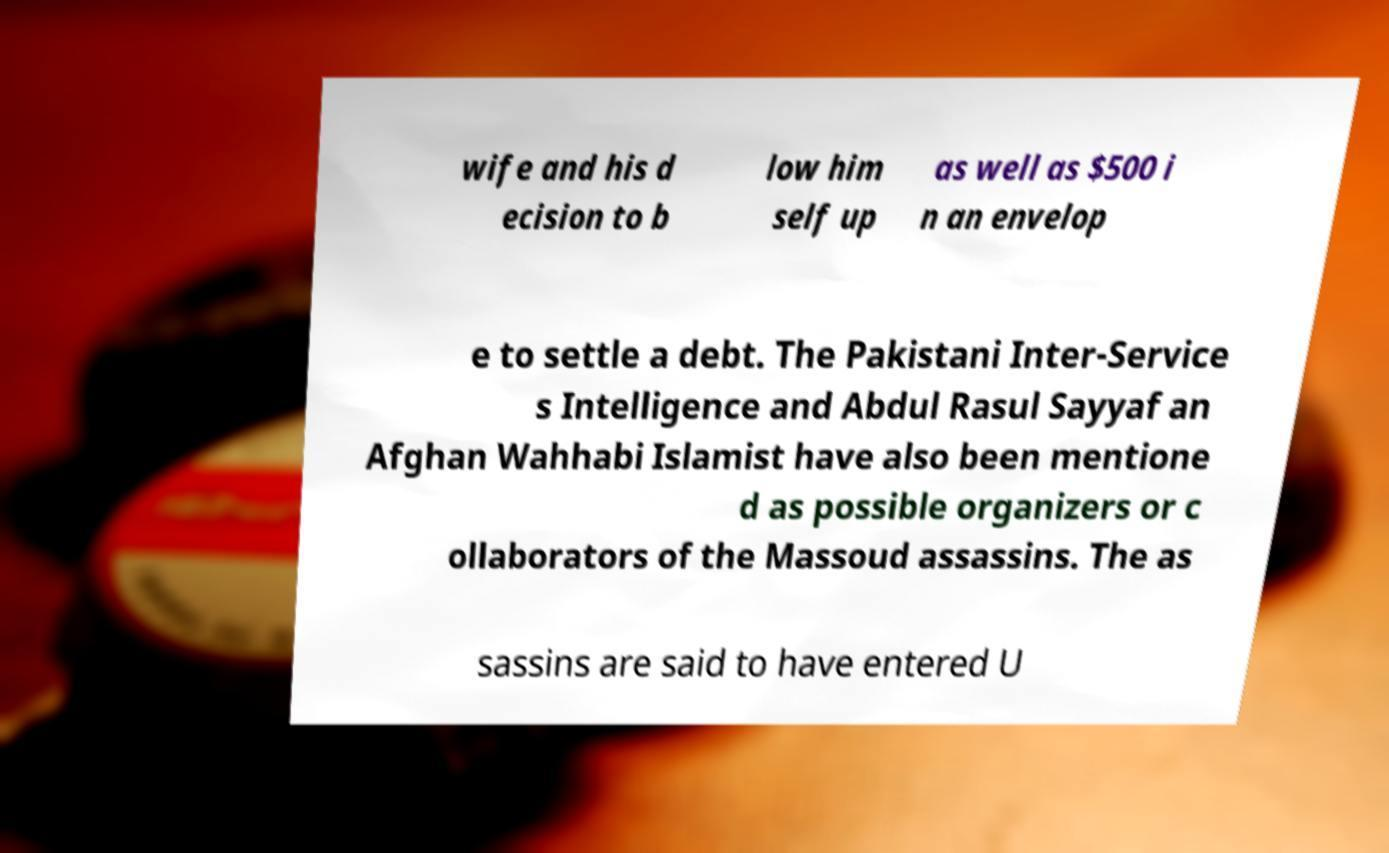Could you assist in decoding the text presented in this image and type it out clearly? wife and his d ecision to b low him self up as well as $500 i n an envelop e to settle a debt. The Pakistani Inter-Service s Intelligence and Abdul Rasul Sayyaf an Afghan Wahhabi Islamist have also been mentione d as possible organizers or c ollaborators of the Massoud assassins. The as sassins are said to have entered U 